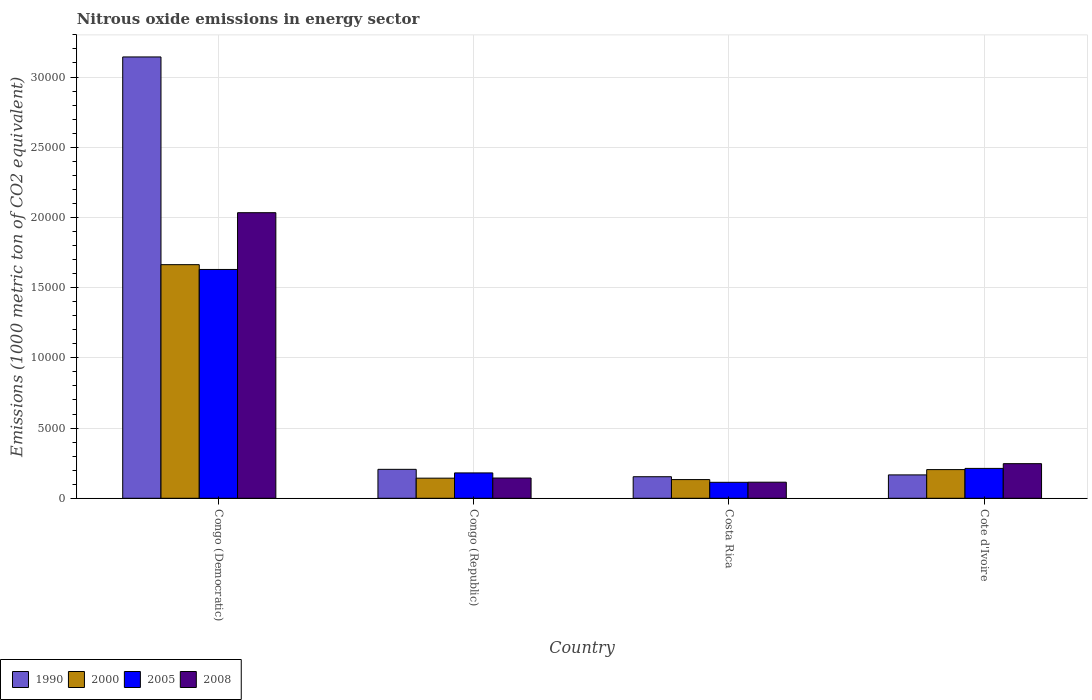How many different coloured bars are there?
Ensure brevity in your answer.  4. Are the number of bars per tick equal to the number of legend labels?
Keep it short and to the point. Yes. Are the number of bars on each tick of the X-axis equal?
Ensure brevity in your answer.  Yes. How many bars are there on the 3rd tick from the right?
Offer a very short reply. 4. What is the label of the 1st group of bars from the left?
Your answer should be compact. Congo (Democratic). What is the amount of nitrous oxide emitted in 1990 in Cote d'Ivoire?
Your answer should be compact. 1664.9. Across all countries, what is the maximum amount of nitrous oxide emitted in 1990?
Offer a terse response. 3.14e+04. Across all countries, what is the minimum amount of nitrous oxide emitted in 2005?
Offer a very short reply. 1138.2. In which country was the amount of nitrous oxide emitted in 2008 maximum?
Offer a very short reply. Congo (Democratic). What is the total amount of nitrous oxide emitted in 1990 in the graph?
Provide a short and direct response. 3.67e+04. What is the difference between the amount of nitrous oxide emitted in 2000 in Congo (Republic) and that in Costa Rica?
Offer a terse response. 100.6. What is the difference between the amount of nitrous oxide emitted in 1990 in Congo (Democratic) and the amount of nitrous oxide emitted in 2005 in Costa Rica?
Offer a terse response. 3.03e+04. What is the average amount of nitrous oxide emitted in 2000 per country?
Ensure brevity in your answer.  5360.8. What is the difference between the amount of nitrous oxide emitted of/in 2005 and amount of nitrous oxide emitted of/in 2000 in Cote d'Ivoire?
Your response must be concise. 86.5. What is the ratio of the amount of nitrous oxide emitted in 2005 in Congo (Democratic) to that in Congo (Republic)?
Make the answer very short. 9.02. What is the difference between the highest and the second highest amount of nitrous oxide emitted in 2008?
Your response must be concise. 1.79e+04. What is the difference between the highest and the lowest amount of nitrous oxide emitted in 2008?
Provide a short and direct response. 1.92e+04. Is it the case that in every country, the sum of the amount of nitrous oxide emitted in 2005 and amount of nitrous oxide emitted in 2008 is greater than the sum of amount of nitrous oxide emitted in 2000 and amount of nitrous oxide emitted in 1990?
Offer a terse response. No. How many bars are there?
Provide a succinct answer. 16. What is the difference between two consecutive major ticks on the Y-axis?
Provide a succinct answer. 5000. How many legend labels are there?
Your answer should be compact. 4. How are the legend labels stacked?
Your answer should be compact. Horizontal. What is the title of the graph?
Give a very brief answer. Nitrous oxide emissions in energy sector. Does "1973" appear as one of the legend labels in the graph?
Keep it short and to the point. No. What is the label or title of the X-axis?
Your response must be concise. Country. What is the label or title of the Y-axis?
Your answer should be very brief. Emissions (1000 metric ton of CO2 equivalent). What is the Emissions (1000 metric ton of CO2 equivalent) in 1990 in Congo (Democratic)?
Your answer should be compact. 3.14e+04. What is the Emissions (1000 metric ton of CO2 equivalent) of 2000 in Congo (Democratic)?
Your response must be concise. 1.66e+04. What is the Emissions (1000 metric ton of CO2 equivalent) of 2005 in Congo (Democratic)?
Provide a short and direct response. 1.63e+04. What is the Emissions (1000 metric ton of CO2 equivalent) of 2008 in Congo (Democratic)?
Your answer should be very brief. 2.03e+04. What is the Emissions (1000 metric ton of CO2 equivalent) in 1990 in Congo (Republic)?
Make the answer very short. 2061.2. What is the Emissions (1000 metric ton of CO2 equivalent) of 2000 in Congo (Republic)?
Provide a short and direct response. 1432.4. What is the Emissions (1000 metric ton of CO2 equivalent) of 2005 in Congo (Republic)?
Provide a succinct answer. 1806.4. What is the Emissions (1000 metric ton of CO2 equivalent) of 2008 in Congo (Republic)?
Keep it short and to the point. 1443.1. What is the Emissions (1000 metric ton of CO2 equivalent) in 1990 in Costa Rica?
Ensure brevity in your answer.  1535. What is the Emissions (1000 metric ton of CO2 equivalent) of 2000 in Costa Rica?
Your answer should be very brief. 1331.8. What is the Emissions (1000 metric ton of CO2 equivalent) in 2005 in Costa Rica?
Keep it short and to the point. 1138.2. What is the Emissions (1000 metric ton of CO2 equivalent) in 2008 in Costa Rica?
Your answer should be very brief. 1145.2. What is the Emissions (1000 metric ton of CO2 equivalent) of 1990 in Cote d'Ivoire?
Your answer should be very brief. 1664.9. What is the Emissions (1000 metric ton of CO2 equivalent) of 2000 in Cote d'Ivoire?
Your answer should be compact. 2041.8. What is the Emissions (1000 metric ton of CO2 equivalent) in 2005 in Cote d'Ivoire?
Offer a terse response. 2128.3. What is the Emissions (1000 metric ton of CO2 equivalent) of 2008 in Cote d'Ivoire?
Keep it short and to the point. 2465.6. Across all countries, what is the maximum Emissions (1000 metric ton of CO2 equivalent) of 1990?
Make the answer very short. 3.14e+04. Across all countries, what is the maximum Emissions (1000 metric ton of CO2 equivalent) of 2000?
Provide a short and direct response. 1.66e+04. Across all countries, what is the maximum Emissions (1000 metric ton of CO2 equivalent) in 2005?
Offer a very short reply. 1.63e+04. Across all countries, what is the maximum Emissions (1000 metric ton of CO2 equivalent) of 2008?
Your answer should be very brief. 2.03e+04. Across all countries, what is the minimum Emissions (1000 metric ton of CO2 equivalent) of 1990?
Make the answer very short. 1535. Across all countries, what is the minimum Emissions (1000 metric ton of CO2 equivalent) of 2000?
Offer a very short reply. 1331.8. Across all countries, what is the minimum Emissions (1000 metric ton of CO2 equivalent) in 2005?
Your answer should be compact. 1138.2. Across all countries, what is the minimum Emissions (1000 metric ton of CO2 equivalent) in 2008?
Give a very brief answer. 1145.2. What is the total Emissions (1000 metric ton of CO2 equivalent) in 1990 in the graph?
Make the answer very short. 3.67e+04. What is the total Emissions (1000 metric ton of CO2 equivalent) of 2000 in the graph?
Offer a very short reply. 2.14e+04. What is the total Emissions (1000 metric ton of CO2 equivalent) of 2005 in the graph?
Your answer should be very brief. 2.14e+04. What is the total Emissions (1000 metric ton of CO2 equivalent) in 2008 in the graph?
Provide a short and direct response. 2.54e+04. What is the difference between the Emissions (1000 metric ton of CO2 equivalent) in 1990 in Congo (Democratic) and that in Congo (Republic)?
Your response must be concise. 2.94e+04. What is the difference between the Emissions (1000 metric ton of CO2 equivalent) of 2000 in Congo (Democratic) and that in Congo (Republic)?
Your answer should be very brief. 1.52e+04. What is the difference between the Emissions (1000 metric ton of CO2 equivalent) in 2005 in Congo (Democratic) and that in Congo (Republic)?
Your answer should be compact. 1.45e+04. What is the difference between the Emissions (1000 metric ton of CO2 equivalent) in 2008 in Congo (Democratic) and that in Congo (Republic)?
Provide a short and direct response. 1.89e+04. What is the difference between the Emissions (1000 metric ton of CO2 equivalent) in 1990 in Congo (Democratic) and that in Costa Rica?
Offer a terse response. 2.99e+04. What is the difference between the Emissions (1000 metric ton of CO2 equivalent) of 2000 in Congo (Democratic) and that in Costa Rica?
Keep it short and to the point. 1.53e+04. What is the difference between the Emissions (1000 metric ton of CO2 equivalent) in 2005 in Congo (Democratic) and that in Costa Rica?
Your response must be concise. 1.52e+04. What is the difference between the Emissions (1000 metric ton of CO2 equivalent) of 2008 in Congo (Democratic) and that in Costa Rica?
Your response must be concise. 1.92e+04. What is the difference between the Emissions (1000 metric ton of CO2 equivalent) in 1990 in Congo (Democratic) and that in Cote d'Ivoire?
Give a very brief answer. 2.98e+04. What is the difference between the Emissions (1000 metric ton of CO2 equivalent) in 2000 in Congo (Democratic) and that in Cote d'Ivoire?
Give a very brief answer. 1.46e+04. What is the difference between the Emissions (1000 metric ton of CO2 equivalent) in 2005 in Congo (Democratic) and that in Cote d'Ivoire?
Your response must be concise. 1.42e+04. What is the difference between the Emissions (1000 metric ton of CO2 equivalent) of 2008 in Congo (Democratic) and that in Cote d'Ivoire?
Provide a succinct answer. 1.79e+04. What is the difference between the Emissions (1000 metric ton of CO2 equivalent) in 1990 in Congo (Republic) and that in Costa Rica?
Your answer should be very brief. 526.2. What is the difference between the Emissions (1000 metric ton of CO2 equivalent) of 2000 in Congo (Republic) and that in Costa Rica?
Make the answer very short. 100.6. What is the difference between the Emissions (1000 metric ton of CO2 equivalent) of 2005 in Congo (Republic) and that in Costa Rica?
Your answer should be very brief. 668.2. What is the difference between the Emissions (1000 metric ton of CO2 equivalent) of 2008 in Congo (Republic) and that in Costa Rica?
Offer a very short reply. 297.9. What is the difference between the Emissions (1000 metric ton of CO2 equivalent) of 1990 in Congo (Republic) and that in Cote d'Ivoire?
Provide a short and direct response. 396.3. What is the difference between the Emissions (1000 metric ton of CO2 equivalent) in 2000 in Congo (Republic) and that in Cote d'Ivoire?
Offer a very short reply. -609.4. What is the difference between the Emissions (1000 metric ton of CO2 equivalent) of 2005 in Congo (Republic) and that in Cote d'Ivoire?
Your answer should be compact. -321.9. What is the difference between the Emissions (1000 metric ton of CO2 equivalent) of 2008 in Congo (Republic) and that in Cote d'Ivoire?
Provide a succinct answer. -1022.5. What is the difference between the Emissions (1000 metric ton of CO2 equivalent) in 1990 in Costa Rica and that in Cote d'Ivoire?
Your answer should be compact. -129.9. What is the difference between the Emissions (1000 metric ton of CO2 equivalent) of 2000 in Costa Rica and that in Cote d'Ivoire?
Provide a short and direct response. -710. What is the difference between the Emissions (1000 metric ton of CO2 equivalent) of 2005 in Costa Rica and that in Cote d'Ivoire?
Make the answer very short. -990.1. What is the difference between the Emissions (1000 metric ton of CO2 equivalent) in 2008 in Costa Rica and that in Cote d'Ivoire?
Your response must be concise. -1320.4. What is the difference between the Emissions (1000 metric ton of CO2 equivalent) in 1990 in Congo (Democratic) and the Emissions (1000 metric ton of CO2 equivalent) in 2000 in Congo (Republic)?
Provide a short and direct response. 3.00e+04. What is the difference between the Emissions (1000 metric ton of CO2 equivalent) of 1990 in Congo (Democratic) and the Emissions (1000 metric ton of CO2 equivalent) of 2005 in Congo (Republic)?
Keep it short and to the point. 2.96e+04. What is the difference between the Emissions (1000 metric ton of CO2 equivalent) of 1990 in Congo (Democratic) and the Emissions (1000 metric ton of CO2 equivalent) of 2008 in Congo (Republic)?
Ensure brevity in your answer.  3.00e+04. What is the difference between the Emissions (1000 metric ton of CO2 equivalent) of 2000 in Congo (Democratic) and the Emissions (1000 metric ton of CO2 equivalent) of 2005 in Congo (Republic)?
Provide a short and direct response. 1.48e+04. What is the difference between the Emissions (1000 metric ton of CO2 equivalent) of 2000 in Congo (Democratic) and the Emissions (1000 metric ton of CO2 equivalent) of 2008 in Congo (Republic)?
Your response must be concise. 1.52e+04. What is the difference between the Emissions (1000 metric ton of CO2 equivalent) in 2005 in Congo (Democratic) and the Emissions (1000 metric ton of CO2 equivalent) in 2008 in Congo (Republic)?
Your answer should be compact. 1.49e+04. What is the difference between the Emissions (1000 metric ton of CO2 equivalent) of 1990 in Congo (Democratic) and the Emissions (1000 metric ton of CO2 equivalent) of 2000 in Costa Rica?
Keep it short and to the point. 3.01e+04. What is the difference between the Emissions (1000 metric ton of CO2 equivalent) of 1990 in Congo (Democratic) and the Emissions (1000 metric ton of CO2 equivalent) of 2005 in Costa Rica?
Offer a terse response. 3.03e+04. What is the difference between the Emissions (1000 metric ton of CO2 equivalent) in 1990 in Congo (Democratic) and the Emissions (1000 metric ton of CO2 equivalent) in 2008 in Costa Rica?
Offer a very short reply. 3.03e+04. What is the difference between the Emissions (1000 metric ton of CO2 equivalent) in 2000 in Congo (Democratic) and the Emissions (1000 metric ton of CO2 equivalent) in 2005 in Costa Rica?
Offer a terse response. 1.55e+04. What is the difference between the Emissions (1000 metric ton of CO2 equivalent) in 2000 in Congo (Democratic) and the Emissions (1000 metric ton of CO2 equivalent) in 2008 in Costa Rica?
Ensure brevity in your answer.  1.55e+04. What is the difference between the Emissions (1000 metric ton of CO2 equivalent) in 2005 in Congo (Democratic) and the Emissions (1000 metric ton of CO2 equivalent) in 2008 in Costa Rica?
Your answer should be compact. 1.51e+04. What is the difference between the Emissions (1000 metric ton of CO2 equivalent) in 1990 in Congo (Democratic) and the Emissions (1000 metric ton of CO2 equivalent) in 2000 in Cote d'Ivoire?
Provide a short and direct response. 2.94e+04. What is the difference between the Emissions (1000 metric ton of CO2 equivalent) of 1990 in Congo (Democratic) and the Emissions (1000 metric ton of CO2 equivalent) of 2005 in Cote d'Ivoire?
Your answer should be compact. 2.93e+04. What is the difference between the Emissions (1000 metric ton of CO2 equivalent) in 1990 in Congo (Democratic) and the Emissions (1000 metric ton of CO2 equivalent) in 2008 in Cote d'Ivoire?
Offer a very short reply. 2.90e+04. What is the difference between the Emissions (1000 metric ton of CO2 equivalent) of 2000 in Congo (Democratic) and the Emissions (1000 metric ton of CO2 equivalent) of 2005 in Cote d'Ivoire?
Your response must be concise. 1.45e+04. What is the difference between the Emissions (1000 metric ton of CO2 equivalent) of 2000 in Congo (Democratic) and the Emissions (1000 metric ton of CO2 equivalent) of 2008 in Cote d'Ivoire?
Your answer should be very brief. 1.42e+04. What is the difference between the Emissions (1000 metric ton of CO2 equivalent) in 2005 in Congo (Democratic) and the Emissions (1000 metric ton of CO2 equivalent) in 2008 in Cote d'Ivoire?
Give a very brief answer. 1.38e+04. What is the difference between the Emissions (1000 metric ton of CO2 equivalent) of 1990 in Congo (Republic) and the Emissions (1000 metric ton of CO2 equivalent) of 2000 in Costa Rica?
Keep it short and to the point. 729.4. What is the difference between the Emissions (1000 metric ton of CO2 equivalent) of 1990 in Congo (Republic) and the Emissions (1000 metric ton of CO2 equivalent) of 2005 in Costa Rica?
Ensure brevity in your answer.  923. What is the difference between the Emissions (1000 metric ton of CO2 equivalent) in 1990 in Congo (Republic) and the Emissions (1000 metric ton of CO2 equivalent) in 2008 in Costa Rica?
Make the answer very short. 916. What is the difference between the Emissions (1000 metric ton of CO2 equivalent) in 2000 in Congo (Republic) and the Emissions (1000 metric ton of CO2 equivalent) in 2005 in Costa Rica?
Keep it short and to the point. 294.2. What is the difference between the Emissions (1000 metric ton of CO2 equivalent) in 2000 in Congo (Republic) and the Emissions (1000 metric ton of CO2 equivalent) in 2008 in Costa Rica?
Ensure brevity in your answer.  287.2. What is the difference between the Emissions (1000 metric ton of CO2 equivalent) of 2005 in Congo (Republic) and the Emissions (1000 metric ton of CO2 equivalent) of 2008 in Costa Rica?
Your answer should be compact. 661.2. What is the difference between the Emissions (1000 metric ton of CO2 equivalent) in 1990 in Congo (Republic) and the Emissions (1000 metric ton of CO2 equivalent) in 2005 in Cote d'Ivoire?
Your response must be concise. -67.1. What is the difference between the Emissions (1000 metric ton of CO2 equivalent) in 1990 in Congo (Republic) and the Emissions (1000 metric ton of CO2 equivalent) in 2008 in Cote d'Ivoire?
Offer a terse response. -404.4. What is the difference between the Emissions (1000 metric ton of CO2 equivalent) of 2000 in Congo (Republic) and the Emissions (1000 metric ton of CO2 equivalent) of 2005 in Cote d'Ivoire?
Keep it short and to the point. -695.9. What is the difference between the Emissions (1000 metric ton of CO2 equivalent) of 2000 in Congo (Republic) and the Emissions (1000 metric ton of CO2 equivalent) of 2008 in Cote d'Ivoire?
Your response must be concise. -1033.2. What is the difference between the Emissions (1000 metric ton of CO2 equivalent) of 2005 in Congo (Republic) and the Emissions (1000 metric ton of CO2 equivalent) of 2008 in Cote d'Ivoire?
Give a very brief answer. -659.2. What is the difference between the Emissions (1000 metric ton of CO2 equivalent) in 1990 in Costa Rica and the Emissions (1000 metric ton of CO2 equivalent) in 2000 in Cote d'Ivoire?
Keep it short and to the point. -506.8. What is the difference between the Emissions (1000 metric ton of CO2 equivalent) of 1990 in Costa Rica and the Emissions (1000 metric ton of CO2 equivalent) of 2005 in Cote d'Ivoire?
Provide a succinct answer. -593.3. What is the difference between the Emissions (1000 metric ton of CO2 equivalent) of 1990 in Costa Rica and the Emissions (1000 metric ton of CO2 equivalent) of 2008 in Cote d'Ivoire?
Provide a short and direct response. -930.6. What is the difference between the Emissions (1000 metric ton of CO2 equivalent) in 2000 in Costa Rica and the Emissions (1000 metric ton of CO2 equivalent) in 2005 in Cote d'Ivoire?
Your answer should be compact. -796.5. What is the difference between the Emissions (1000 metric ton of CO2 equivalent) of 2000 in Costa Rica and the Emissions (1000 metric ton of CO2 equivalent) of 2008 in Cote d'Ivoire?
Provide a short and direct response. -1133.8. What is the difference between the Emissions (1000 metric ton of CO2 equivalent) in 2005 in Costa Rica and the Emissions (1000 metric ton of CO2 equivalent) in 2008 in Cote d'Ivoire?
Keep it short and to the point. -1327.4. What is the average Emissions (1000 metric ton of CO2 equivalent) of 1990 per country?
Offer a very short reply. 9172.62. What is the average Emissions (1000 metric ton of CO2 equivalent) of 2000 per country?
Your response must be concise. 5360.8. What is the average Emissions (1000 metric ton of CO2 equivalent) of 2005 per country?
Give a very brief answer. 5341.98. What is the average Emissions (1000 metric ton of CO2 equivalent) of 2008 per country?
Your response must be concise. 6347.9. What is the difference between the Emissions (1000 metric ton of CO2 equivalent) of 1990 and Emissions (1000 metric ton of CO2 equivalent) of 2000 in Congo (Democratic)?
Offer a very short reply. 1.48e+04. What is the difference between the Emissions (1000 metric ton of CO2 equivalent) of 1990 and Emissions (1000 metric ton of CO2 equivalent) of 2005 in Congo (Democratic)?
Give a very brief answer. 1.51e+04. What is the difference between the Emissions (1000 metric ton of CO2 equivalent) in 1990 and Emissions (1000 metric ton of CO2 equivalent) in 2008 in Congo (Democratic)?
Keep it short and to the point. 1.11e+04. What is the difference between the Emissions (1000 metric ton of CO2 equivalent) of 2000 and Emissions (1000 metric ton of CO2 equivalent) of 2005 in Congo (Democratic)?
Your answer should be compact. 342.2. What is the difference between the Emissions (1000 metric ton of CO2 equivalent) in 2000 and Emissions (1000 metric ton of CO2 equivalent) in 2008 in Congo (Democratic)?
Give a very brief answer. -3700.5. What is the difference between the Emissions (1000 metric ton of CO2 equivalent) of 2005 and Emissions (1000 metric ton of CO2 equivalent) of 2008 in Congo (Democratic)?
Your answer should be compact. -4042.7. What is the difference between the Emissions (1000 metric ton of CO2 equivalent) in 1990 and Emissions (1000 metric ton of CO2 equivalent) in 2000 in Congo (Republic)?
Your answer should be compact. 628.8. What is the difference between the Emissions (1000 metric ton of CO2 equivalent) of 1990 and Emissions (1000 metric ton of CO2 equivalent) of 2005 in Congo (Republic)?
Offer a terse response. 254.8. What is the difference between the Emissions (1000 metric ton of CO2 equivalent) in 1990 and Emissions (1000 metric ton of CO2 equivalent) in 2008 in Congo (Republic)?
Make the answer very short. 618.1. What is the difference between the Emissions (1000 metric ton of CO2 equivalent) in 2000 and Emissions (1000 metric ton of CO2 equivalent) in 2005 in Congo (Republic)?
Provide a short and direct response. -374. What is the difference between the Emissions (1000 metric ton of CO2 equivalent) of 2000 and Emissions (1000 metric ton of CO2 equivalent) of 2008 in Congo (Republic)?
Provide a short and direct response. -10.7. What is the difference between the Emissions (1000 metric ton of CO2 equivalent) in 2005 and Emissions (1000 metric ton of CO2 equivalent) in 2008 in Congo (Republic)?
Ensure brevity in your answer.  363.3. What is the difference between the Emissions (1000 metric ton of CO2 equivalent) of 1990 and Emissions (1000 metric ton of CO2 equivalent) of 2000 in Costa Rica?
Give a very brief answer. 203.2. What is the difference between the Emissions (1000 metric ton of CO2 equivalent) in 1990 and Emissions (1000 metric ton of CO2 equivalent) in 2005 in Costa Rica?
Provide a short and direct response. 396.8. What is the difference between the Emissions (1000 metric ton of CO2 equivalent) in 1990 and Emissions (1000 metric ton of CO2 equivalent) in 2008 in Costa Rica?
Offer a terse response. 389.8. What is the difference between the Emissions (1000 metric ton of CO2 equivalent) of 2000 and Emissions (1000 metric ton of CO2 equivalent) of 2005 in Costa Rica?
Keep it short and to the point. 193.6. What is the difference between the Emissions (1000 metric ton of CO2 equivalent) of 2000 and Emissions (1000 metric ton of CO2 equivalent) of 2008 in Costa Rica?
Give a very brief answer. 186.6. What is the difference between the Emissions (1000 metric ton of CO2 equivalent) of 1990 and Emissions (1000 metric ton of CO2 equivalent) of 2000 in Cote d'Ivoire?
Provide a succinct answer. -376.9. What is the difference between the Emissions (1000 metric ton of CO2 equivalent) of 1990 and Emissions (1000 metric ton of CO2 equivalent) of 2005 in Cote d'Ivoire?
Your answer should be very brief. -463.4. What is the difference between the Emissions (1000 metric ton of CO2 equivalent) of 1990 and Emissions (1000 metric ton of CO2 equivalent) of 2008 in Cote d'Ivoire?
Give a very brief answer. -800.7. What is the difference between the Emissions (1000 metric ton of CO2 equivalent) in 2000 and Emissions (1000 metric ton of CO2 equivalent) in 2005 in Cote d'Ivoire?
Give a very brief answer. -86.5. What is the difference between the Emissions (1000 metric ton of CO2 equivalent) of 2000 and Emissions (1000 metric ton of CO2 equivalent) of 2008 in Cote d'Ivoire?
Provide a short and direct response. -423.8. What is the difference between the Emissions (1000 metric ton of CO2 equivalent) in 2005 and Emissions (1000 metric ton of CO2 equivalent) in 2008 in Cote d'Ivoire?
Provide a short and direct response. -337.3. What is the ratio of the Emissions (1000 metric ton of CO2 equivalent) of 1990 in Congo (Democratic) to that in Congo (Republic)?
Offer a very short reply. 15.25. What is the ratio of the Emissions (1000 metric ton of CO2 equivalent) of 2000 in Congo (Democratic) to that in Congo (Republic)?
Keep it short and to the point. 11.61. What is the ratio of the Emissions (1000 metric ton of CO2 equivalent) of 2005 in Congo (Democratic) to that in Congo (Republic)?
Provide a succinct answer. 9.02. What is the ratio of the Emissions (1000 metric ton of CO2 equivalent) in 2008 in Congo (Democratic) to that in Congo (Republic)?
Your answer should be compact. 14.09. What is the ratio of the Emissions (1000 metric ton of CO2 equivalent) in 1990 in Congo (Democratic) to that in Costa Rica?
Offer a terse response. 20.48. What is the ratio of the Emissions (1000 metric ton of CO2 equivalent) of 2000 in Congo (Democratic) to that in Costa Rica?
Offer a very short reply. 12.49. What is the ratio of the Emissions (1000 metric ton of CO2 equivalent) in 2005 in Congo (Democratic) to that in Costa Rica?
Provide a succinct answer. 14.32. What is the ratio of the Emissions (1000 metric ton of CO2 equivalent) in 2008 in Congo (Democratic) to that in Costa Rica?
Provide a short and direct response. 17.76. What is the ratio of the Emissions (1000 metric ton of CO2 equivalent) in 1990 in Congo (Democratic) to that in Cote d'Ivoire?
Make the answer very short. 18.88. What is the ratio of the Emissions (1000 metric ton of CO2 equivalent) in 2000 in Congo (Democratic) to that in Cote d'Ivoire?
Offer a terse response. 8.15. What is the ratio of the Emissions (1000 metric ton of CO2 equivalent) of 2005 in Congo (Democratic) to that in Cote d'Ivoire?
Offer a very short reply. 7.66. What is the ratio of the Emissions (1000 metric ton of CO2 equivalent) of 2008 in Congo (Democratic) to that in Cote d'Ivoire?
Provide a succinct answer. 8.25. What is the ratio of the Emissions (1000 metric ton of CO2 equivalent) of 1990 in Congo (Republic) to that in Costa Rica?
Provide a succinct answer. 1.34. What is the ratio of the Emissions (1000 metric ton of CO2 equivalent) in 2000 in Congo (Republic) to that in Costa Rica?
Your response must be concise. 1.08. What is the ratio of the Emissions (1000 metric ton of CO2 equivalent) in 2005 in Congo (Republic) to that in Costa Rica?
Provide a short and direct response. 1.59. What is the ratio of the Emissions (1000 metric ton of CO2 equivalent) of 2008 in Congo (Republic) to that in Costa Rica?
Make the answer very short. 1.26. What is the ratio of the Emissions (1000 metric ton of CO2 equivalent) in 1990 in Congo (Republic) to that in Cote d'Ivoire?
Offer a terse response. 1.24. What is the ratio of the Emissions (1000 metric ton of CO2 equivalent) in 2000 in Congo (Republic) to that in Cote d'Ivoire?
Your response must be concise. 0.7. What is the ratio of the Emissions (1000 metric ton of CO2 equivalent) of 2005 in Congo (Republic) to that in Cote d'Ivoire?
Your answer should be very brief. 0.85. What is the ratio of the Emissions (1000 metric ton of CO2 equivalent) of 2008 in Congo (Republic) to that in Cote d'Ivoire?
Your response must be concise. 0.59. What is the ratio of the Emissions (1000 metric ton of CO2 equivalent) in 1990 in Costa Rica to that in Cote d'Ivoire?
Your response must be concise. 0.92. What is the ratio of the Emissions (1000 metric ton of CO2 equivalent) of 2000 in Costa Rica to that in Cote d'Ivoire?
Provide a succinct answer. 0.65. What is the ratio of the Emissions (1000 metric ton of CO2 equivalent) of 2005 in Costa Rica to that in Cote d'Ivoire?
Your answer should be very brief. 0.53. What is the ratio of the Emissions (1000 metric ton of CO2 equivalent) in 2008 in Costa Rica to that in Cote d'Ivoire?
Your answer should be very brief. 0.46. What is the difference between the highest and the second highest Emissions (1000 metric ton of CO2 equivalent) of 1990?
Your answer should be compact. 2.94e+04. What is the difference between the highest and the second highest Emissions (1000 metric ton of CO2 equivalent) in 2000?
Offer a very short reply. 1.46e+04. What is the difference between the highest and the second highest Emissions (1000 metric ton of CO2 equivalent) in 2005?
Offer a terse response. 1.42e+04. What is the difference between the highest and the second highest Emissions (1000 metric ton of CO2 equivalent) in 2008?
Your response must be concise. 1.79e+04. What is the difference between the highest and the lowest Emissions (1000 metric ton of CO2 equivalent) in 1990?
Make the answer very short. 2.99e+04. What is the difference between the highest and the lowest Emissions (1000 metric ton of CO2 equivalent) of 2000?
Offer a very short reply. 1.53e+04. What is the difference between the highest and the lowest Emissions (1000 metric ton of CO2 equivalent) in 2005?
Provide a short and direct response. 1.52e+04. What is the difference between the highest and the lowest Emissions (1000 metric ton of CO2 equivalent) in 2008?
Keep it short and to the point. 1.92e+04. 